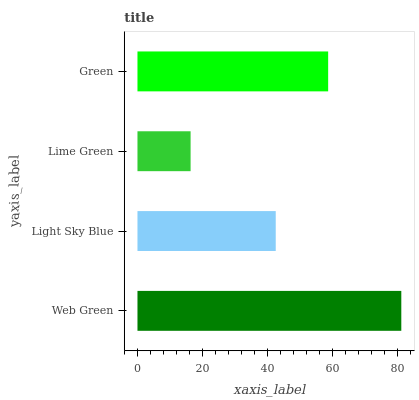Is Lime Green the minimum?
Answer yes or no. Yes. Is Web Green the maximum?
Answer yes or no. Yes. Is Light Sky Blue the minimum?
Answer yes or no. No. Is Light Sky Blue the maximum?
Answer yes or no. No. Is Web Green greater than Light Sky Blue?
Answer yes or no. Yes. Is Light Sky Blue less than Web Green?
Answer yes or no. Yes. Is Light Sky Blue greater than Web Green?
Answer yes or no. No. Is Web Green less than Light Sky Blue?
Answer yes or no. No. Is Green the high median?
Answer yes or no. Yes. Is Light Sky Blue the low median?
Answer yes or no. Yes. Is Light Sky Blue the high median?
Answer yes or no. No. Is Lime Green the low median?
Answer yes or no. No. 